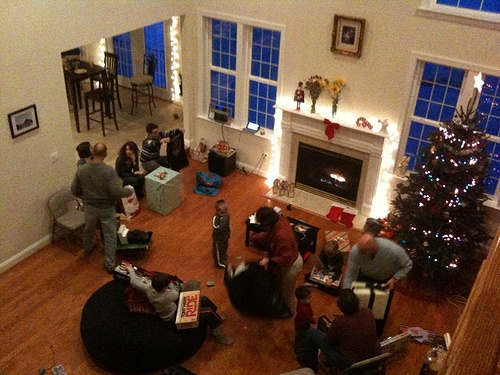Describe the objects in this image and their specific colors. I can see people in tan, black, and gray tones, people in tan, black, maroon, and gray tones, people in tan, black, maroon, and brown tones, people in tan, black, maroon, and gray tones, and people in tan, black, maroon, and gray tones in this image. 